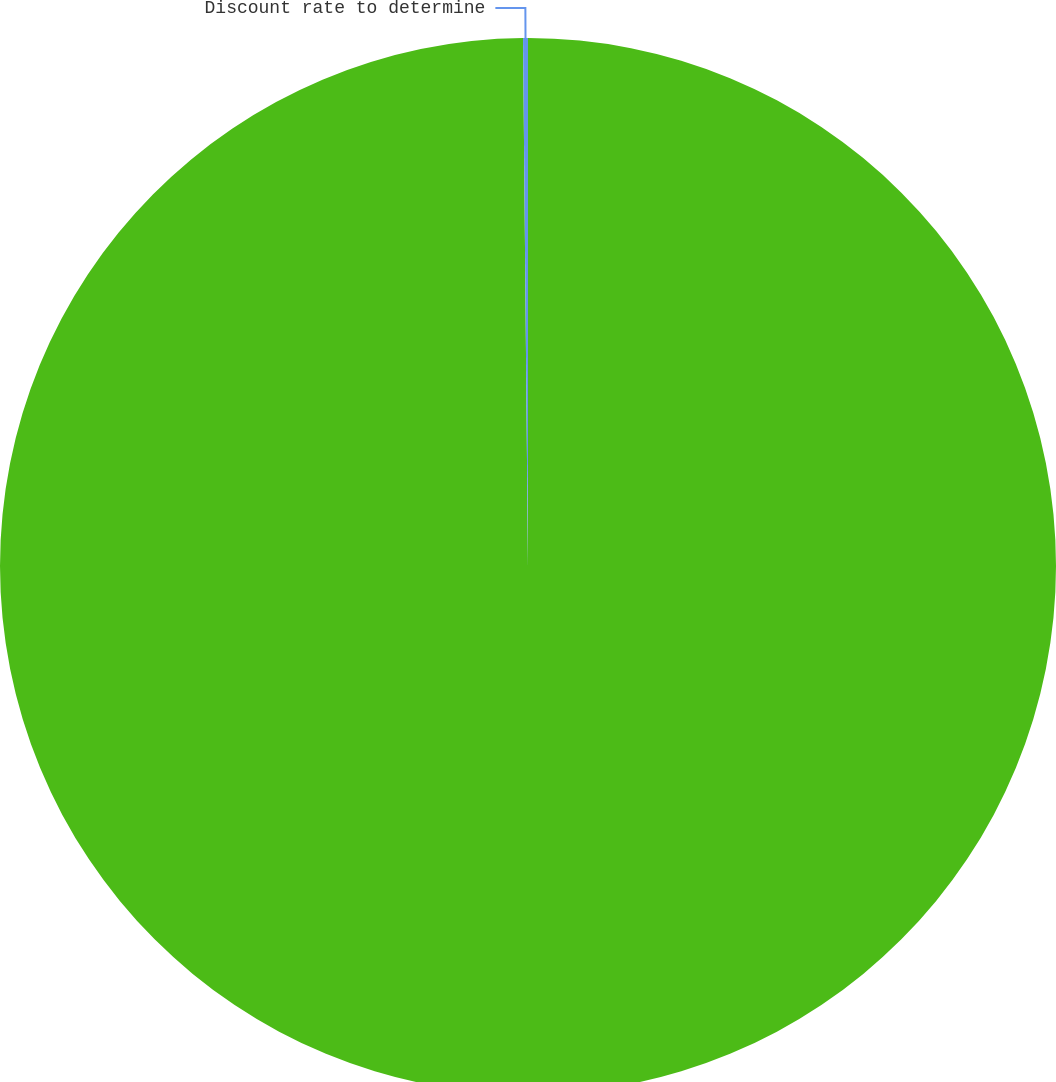Convert chart. <chart><loc_0><loc_0><loc_500><loc_500><pie_chart><fcel>Cost assumptions for fiscal<fcel>Discount rate to determine<nl><fcel>99.85%<fcel>0.15%<nl></chart> 